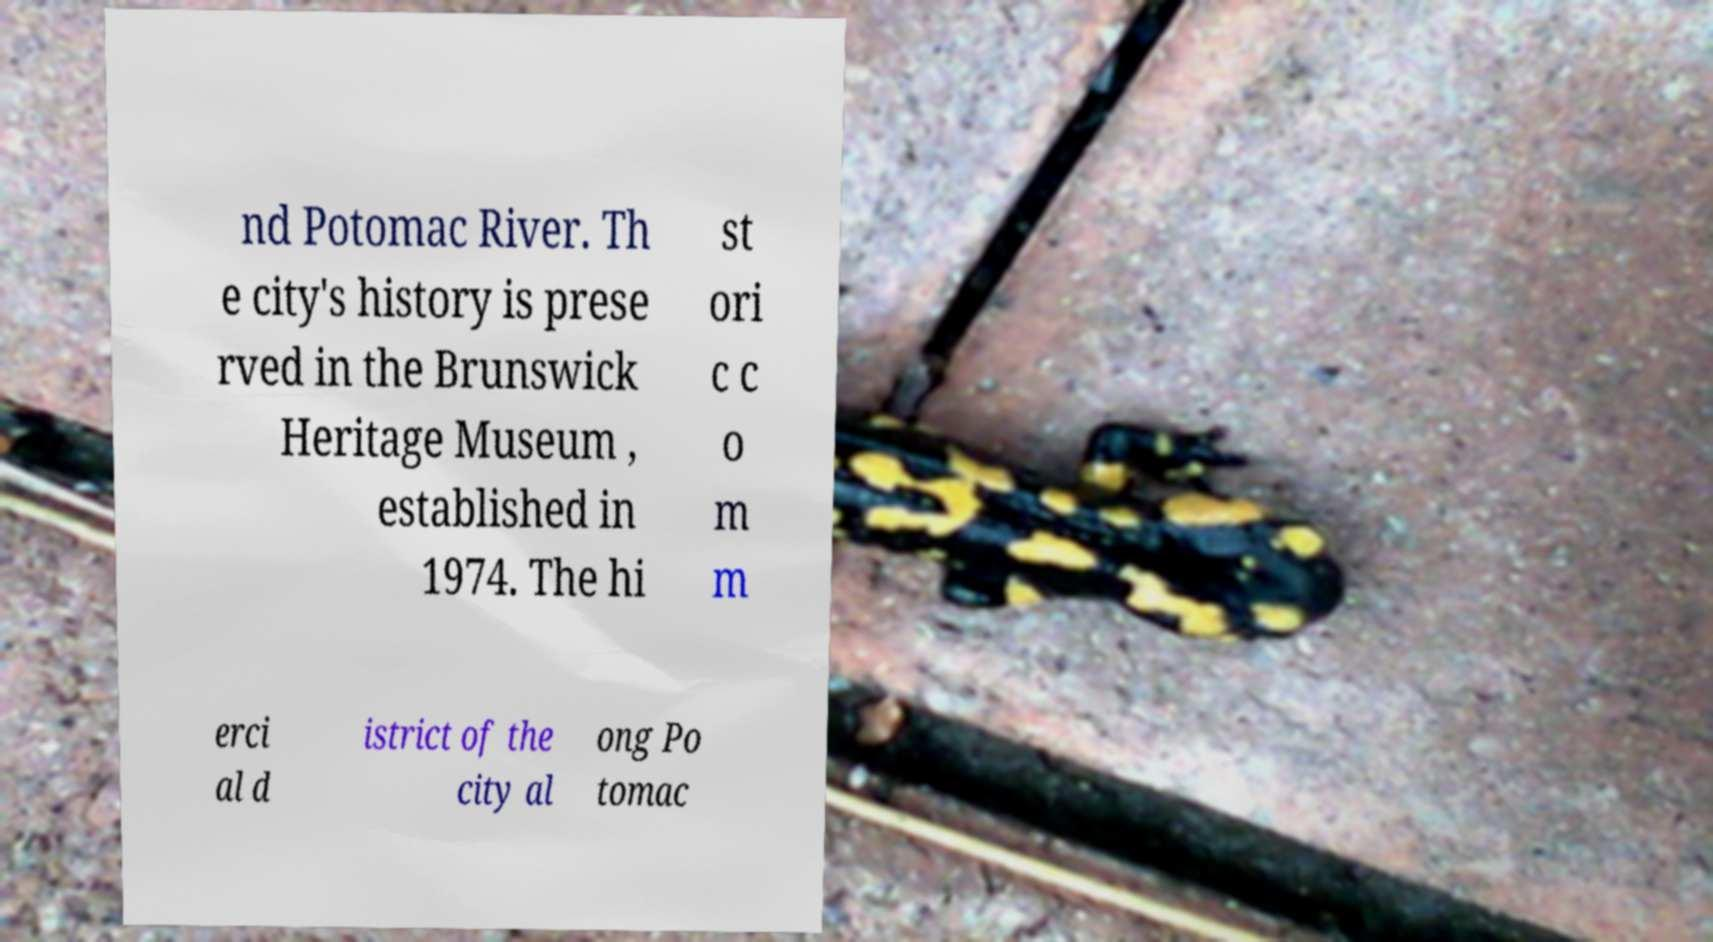There's text embedded in this image that I need extracted. Can you transcribe it verbatim? nd Potomac River. Th e city's history is prese rved in the Brunswick Heritage Museum , established in 1974. The hi st ori c c o m m erci al d istrict of the city al ong Po tomac 